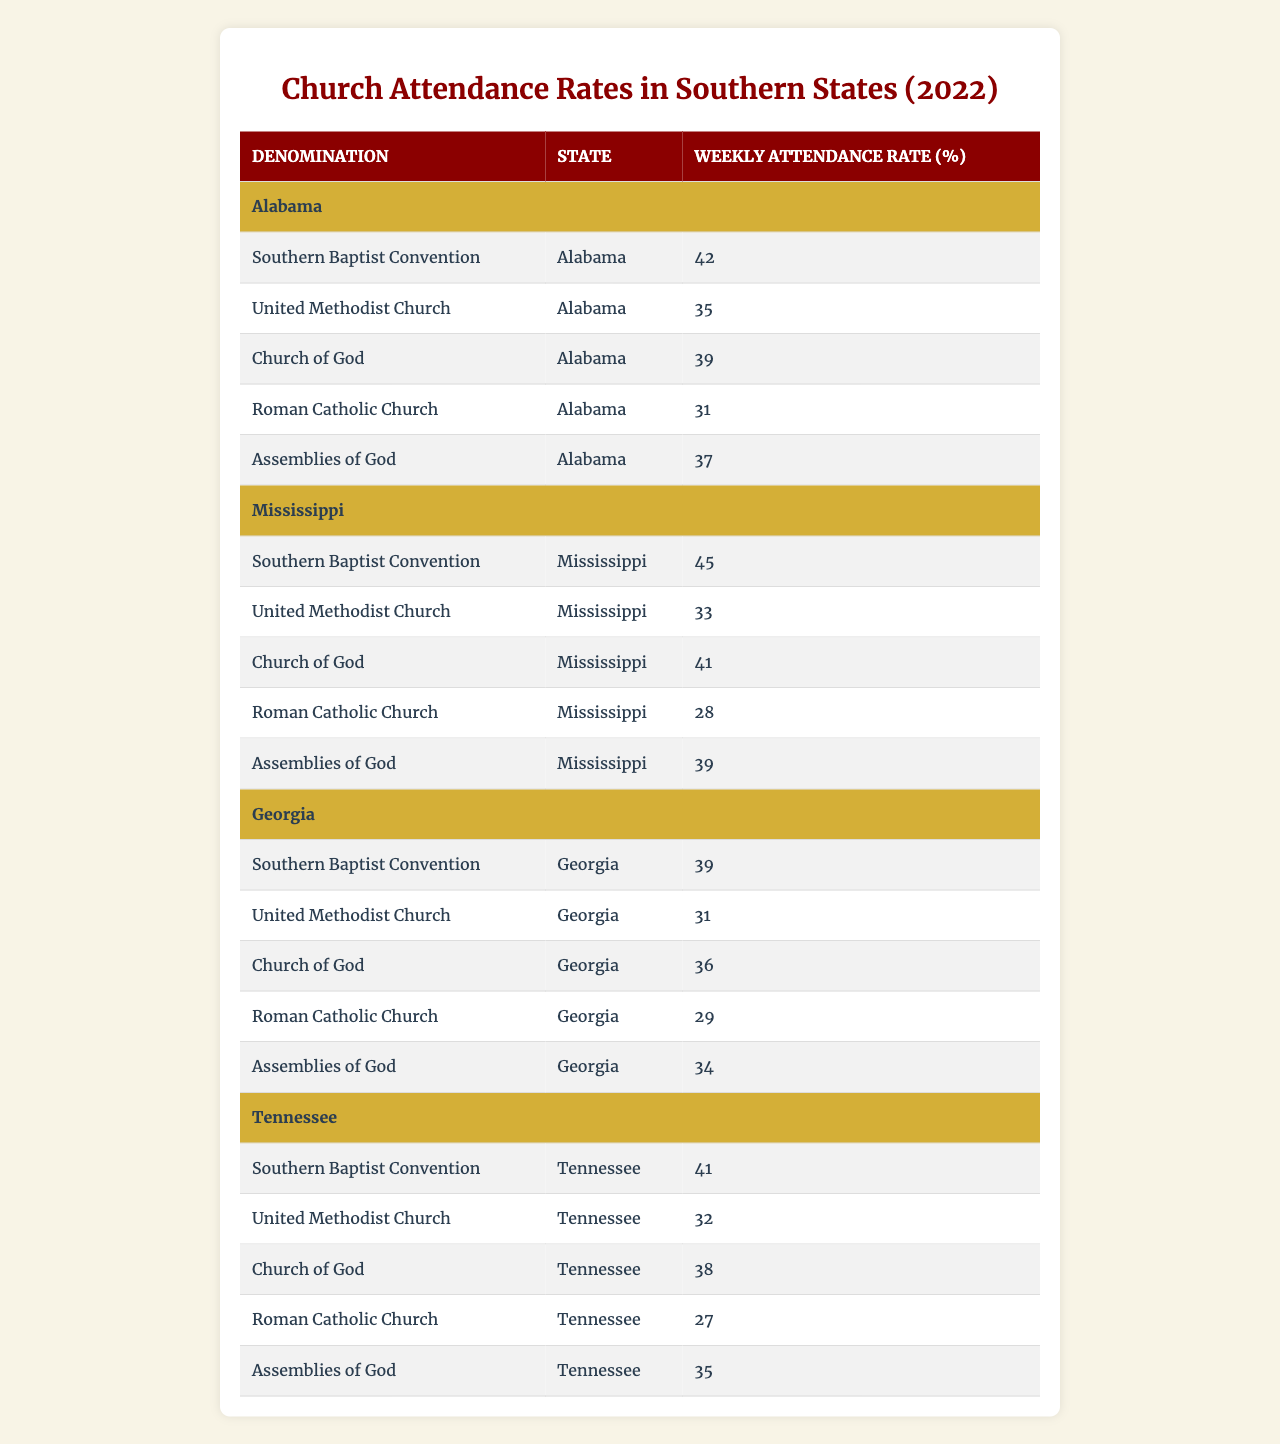What is the highest weekly attendance rate among the denominations in Alabama? Looking at the Alabama data, the Southern Baptist Convention has the highest attendance rate at 42%.
Answer: 42% Which denomination has the lowest attendance rate in Mississippi? In the Mississippi data, the Roman Catholic Church has the lowest attendance rate at 28%.
Answer: 28% What's the average weekly attendance rate for the Southern Baptist Convention across all states listed? The attendance rates for the Southern Baptist Convention are 42, 45, 39, and 41. Summing these gives 42 + 45 + 39 + 41 = 167. Dividing by the number of states (4) gives an average of 167 / 4 = 41.75.
Answer: 41.75 Are attendance rates generally higher for the Southern Baptist Convention compared to the United Methodist Church in Alabama? In Alabama, the Southern Baptist Convention has an attendance rate of 42%, while the United Methodist Church has a rate of 35%. Since 42% is greater than 35%, this statement is true.
Answer: Yes Which state has the highest average attendance rate across all denominations listed? First, calculate the average attendance for each state: Alabama (42 + 35 + 39 + 31 + 37 = 204 / 5 = 40.8), Mississippi (45 + 33 + 41 + 28 + 39 = 186 / 5 = 37.2), Georgia (39 + 31 + 36 + 29 + 34 = 168 / 5 = 33.6), Tennessee (41 + 32 + 38 + 27 + 35 = 173 / 5 = 34.6). Alabama has the highest average at 40.8%.
Answer: Alabama What is the difference in weekly attendance rates between the Assemblies of God in Alabama and Georgia? In Alabama, the Assemblies of God has a rate of 37%, while in Georgia, it is 34%. The difference is 37% - 34% = 3%.
Answer: 3% 